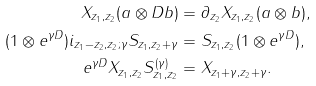Convert formula to latex. <formula><loc_0><loc_0><loc_500><loc_500>X _ { z _ { 1 } , z _ { 2 } } ( a \otimes D b ) & = \partial _ { z _ { 2 } } X _ { z _ { 1 } , z _ { 2 } } ( a \otimes b ) , \\ ( 1 \otimes e ^ { \gamma D } ) i _ { z _ { 1 } - z _ { 2 } , z _ { 2 } ; \gamma } S _ { z _ { 1 } , z _ { 2 } + \gamma } & = S _ { z _ { 1 } , z _ { 2 } } ( 1 \otimes e ^ { \gamma D } ) , \\ e ^ { \gamma D } X _ { z _ { 1 } , z _ { 2 } } S ^ { ( \gamma ) } _ { z _ { 1 } , z _ { 2 } } & = X _ { z _ { 1 } + \gamma , z _ { 2 } + \gamma } .</formula> 